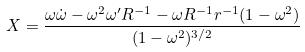<formula> <loc_0><loc_0><loc_500><loc_500>X = \frac { \omega \dot { \omega } - \omega ^ { 2 } \omega ^ { \prime } R ^ { - 1 } - \omega R ^ { - 1 } r ^ { - 1 } ( 1 - \omega ^ { 2 } ) } { ( 1 - \omega ^ { 2 } ) ^ { 3 / 2 } }</formula> 